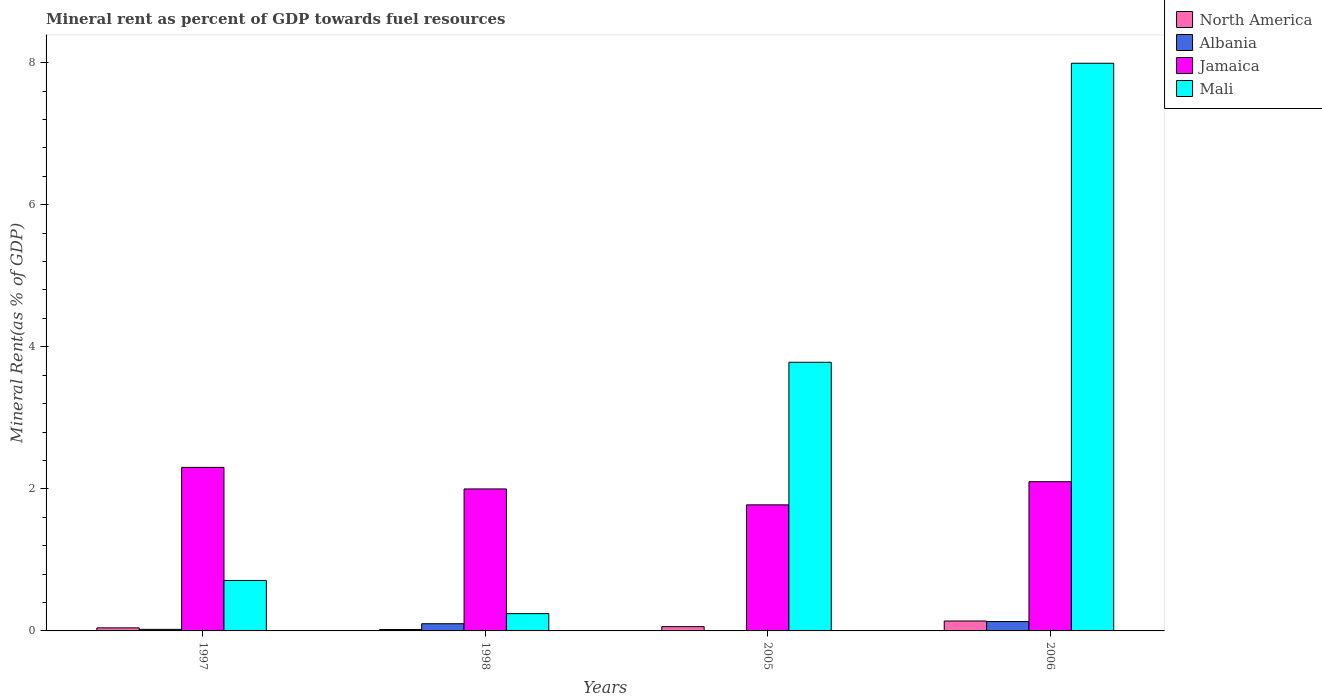How many different coloured bars are there?
Make the answer very short. 4. Are the number of bars per tick equal to the number of legend labels?
Your response must be concise. Yes. What is the mineral rent in Jamaica in 2006?
Keep it short and to the point. 2.1. Across all years, what is the maximum mineral rent in Mali?
Offer a very short reply. 7.99. Across all years, what is the minimum mineral rent in North America?
Provide a short and direct response. 0.02. In which year was the mineral rent in Mali maximum?
Provide a short and direct response. 2006. What is the total mineral rent in North America in the graph?
Provide a succinct answer. 0.26. What is the difference between the mineral rent in Albania in 1997 and that in 1998?
Ensure brevity in your answer.  -0.08. What is the difference between the mineral rent in Mali in 2005 and the mineral rent in Albania in 1998?
Offer a very short reply. 3.68. What is the average mineral rent in Jamaica per year?
Offer a terse response. 2.04. In the year 2005, what is the difference between the mineral rent in North America and mineral rent in Albania?
Make the answer very short. 0.06. What is the ratio of the mineral rent in Jamaica in 1998 to that in 2006?
Offer a very short reply. 0.95. Is the difference between the mineral rent in North America in 1997 and 2006 greater than the difference between the mineral rent in Albania in 1997 and 2006?
Ensure brevity in your answer.  Yes. What is the difference between the highest and the second highest mineral rent in North America?
Offer a very short reply. 0.08. What is the difference between the highest and the lowest mineral rent in Mali?
Your response must be concise. 7.75. In how many years, is the mineral rent in Albania greater than the average mineral rent in Albania taken over all years?
Offer a terse response. 2. Is the sum of the mineral rent in Jamaica in 1998 and 2005 greater than the maximum mineral rent in Albania across all years?
Keep it short and to the point. Yes. Is it the case that in every year, the sum of the mineral rent in Mali and mineral rent in North America is greater than the sum of mineral rent in Albania and mineral rent in Jamaica?
Provide a short and direct response. Yes. What does the 3rd bar from the left in 2006 represents?
Provide a short and direct response. Jamaica. Are all the bars in the graph horizontal?
Your response must be concise. No. How many years are there in the graph?
Give a very brief answer. 4. Does the graph contain any zero values?
Offer a very short reply. No. Does the graph contain grids?
Keep it short and to the point. No. Where does the legend appear in the graph?
Offer a terse response. Top right. What is the title of the graph?
Your answer should be compact. Mineral rent as percent of GDP towards fuel resources. Does "United Arab Emirates" appear as one of the legend labels in the graph?
Keep it short and to the point. No. What is the label or title of the X-axis?
Keep it short and to the point. Years. What is the label or title of the Y-axis?
Your answer should be very brief. Mineral Rent(as % of GDP). What is the Mineral Rent(as % of GDP) in North America in 1997?
Your answer should be very brief. 0.04. What is the Mineral Rent(as % of GDP) in Albania in 1997?
Keep it short and to the point. 0.02. What is the Mineral Rent(as % of GDP) of Jamaica in 1997?
Give a very brief answer. 2.3. What is the Mineral Rent(as % of GDP) of Mali in 1997?
Your response must be concise. 0.71. What is the Mineral Rent(as % of GDP) in North America in 1998?
Provide a short and direct response. 0.02. What is the Mineral Rent(as % of GDP) in Albania in 1998?
Give a very brief answer. 0.1. What is the Mineral Rent(as % of GDP) of Jamaica in 1998?
Ensure brevity in your answer.  2. What is the Mineral Rent(as % of GDP) of Mali in 1998?
Offer a very short reply. 0.24. What is the Mineral Rent(as % of GDP) in North America in 2005?
Make the answer very short. 0.06. What is the Mineral Rent(as % of GDP) in Albania in 2005?
Give a very brief answer. 0. What is the Mineral Rent(as % of GDP) in Jamaica in 2005?
Provide a succinct answer. 1.77. What is the Mineral Rent(as % of GDP) in Mali in 2005?
Offer a very short reply. 3.78. What is the Mineral Rent(as % of GDP) of North America in 2006?
Your answer should be compact. 0.14. What is the Mineral Rent(as % of GDP) of Albania in 2006?
Your response must be concise. 0.13. What is the Mineral Rent(as % of GDP) in Jamaica in 2006?
Make the answer very short. 2.1. What is the Mineral Rent(as % of GDP) of Mali in 2006?
Ensure brevity in your answer.  7.99. Across all years, what is the maximum Mineral Rent(as % of GDP) in North America?
Your answer should be very brief. 0.14. Across all years, what is the maximum Mineral Rent(as % of GDP) in Albania?
Offer a very short reply. 0.13. Across all years, what is the maximum Mineral Rent(as % of GDP) of Jamaica?
Provide a short and direct response. 2.3. Across all years, what is the maximum Mineral Rent(as % of GDP) in Mali?
Your answer should be compact. 7.99. Across all years, what is the minimum Mineral Rent(as % of GDP) in North America?
Your answer should be very brief. 0.02. Across all years, what is the minimum Mineral Rent(as % of GDP) of Albania?
Make the answer very short. 0. Across all years, what is the minimum Mineral Rent(as % of GDP) in Jamaica?
Your answer should be very brief. 1.77. Across all years, what is the minimum Mineral Rent(as % of GDP) in Mali?
Ensure brevity in your answer.  0.24. What is the total Mineral Rent(as % of GDP) of North America in the graph?
Provide a succinct answer. 0.26. What is the total Mineral Rent(as % of GDP) in Albania in the graph?
Make the answer very short. 0.26. What is the total Mineral Rent(as % of GDP) of Jamaica in the graph?
Offer a terse response. 8.18. What is the total Mineral Rent(as % of GDP) of Mali in the graph?
Your response must be concise. 12.73. What is the difference between the Mineral Rent(as % of GDP) of North America in 1997 and that in 1998?
Provide a short and direct response. 0.02. What is the difference between the Mineral Rent(as % of GDP) in Albania in 1997 and that in 1998?
Ensure brevity in your answer.  -0.08. What is the difference between the Mineral Rent(as % of GDP) of Jamaica in 1997 and that in 1998?
Your answer should be compact. 0.3. What is the difference between the Mineral Rent(as % of GDP) in Mali in 1997 and that in 1998?
Your answer should be compact. 0.47. What is the difference between the Mineral Rent(as % of GDP) of North America in 1997 and that in 2005?
Your answer should be very brief. -0.02. What is the difference between the Mineral Rent(as % of GDP) of Albania in 1997 and that in 2005?
Provide a succinct answer. 0.02. What is the difference between the Mineral Rent(as % of GDP) in Jamaica in 1997 and that in 2005?
Make the answer very short. 0.53. What is the difference between the Mineral Rent(as % of GDP) in Mali in 1997 and that in 2005?
Make the answer very short. -3.07. What is the difference between the Mineral Rent(as % of GDP) in North America in 1997 and that in 2006?
Give a very brief answer. -0.1. What is the difference between the Mineral Rent(as % of GDP) in Albania in 1997 and that in 2006?
Ensure brevity in your answer.  -0.11. What is the difference between the Mineral Rent(as % of GDP) in Jamaica in 1997 and that in 2006?
Offer a terse response. 0.2. What is the difference between the Mineral Rent(as % of GDP) in Mali in 1997 and that in 2006?
Provide a succinct answer. -7.28. What is the difference between the Mineral Rent(as % of GDP) in North America in 1998 and that in 2005?
Offer a terse response. -0.04. What is the difference between the Mineral Rent(as % of GDP) in Albania in 1998 and that in 2005?
Offer a terse response. 0.1. What is the difference between the Mineral Rent(as % of GDP) of Jamaica in 1998 and that in 2005?
Offer a terse response. 0.22. What is the difference between the Mineral Rent(as % of GDP) of Mali in 1998 and that in 2005?
Provide a short and direct response. -3.54. What is the difference between the Mineral Rent(as % of GDP) in North America in 1998 and that in 2006?
Provide a succinct answer. -0.12. What is the difference between the Mineral Rent(as % of GDP) of Albania in 1998 and that in 2006?
Your answer should be very brief. -0.03. What is the difference between the Mineral Rent(as % of GDP) in Jamaica in 1998 and that in 2006?
Your answer should be compact. -0.1. What is the difference between the Mineral Rent(as % of GDP) of Mali in 1998 and that in 2006?
Make the answer very short. -7.75. What is the difference between the Mineral Rent(as % of GDP) in North America in 2005 and that in 2006?
Provide a succinct answer. -0.08. What is the difference between the Mineral Rent(as % of GDP) in Albania in 2005 and that in 2006?
Ensure brevity in your answer.  -0.13. What is the difference between the Mineral Rent(as % of GDP) of Jamaica in 2005 and that in 2006?
Your answer should be compact. -0.33. What is the difference between the Mineral Rent(as % of GDP) in Mali in 2005 and that in 2006?
Offer a very short reply. -4.21. What is the difference between the Mineral Rent(as % of GDP) of North America in 1997 and the Mineral Rent(as % of GDP) of Albania in 1998?
Your answer should be compact. -0.06. What is the difference between the Mineral Rent(as % of GDP) of North America in 1997 and the Mineral Rent(as % of GDP) of Jamaica in 1998?
Your answer should be compact. -1.96. What is the difference between the Mineral Rent(as % of GDP) of North America in 1997 and the Mineral Rent(as % of GDP) of Mali in 1998?
Make the answer very short. -0.2. What is the difference between the Mineral Rent(as % of GDP) in Albania in 1997 and the Mineral Rent(as % of GDP) in Jamaica in 1998?
Give a very brief answer. -1.98. What is the difference between the Mineral Rent(as % of GDP) in Albania in 1997 and the Mineral Rent(as % of GDP) in Mali in 1998?
Keep it short and to the point. -0.22. What is the difference between the Mineral Rent(as % of GDP) of Jamaica in 1997 and the Mineral Rent(as % of GDP) of Mali in 1998?
Offer a terse response. 2.06. What is the difference between the Mineral Rent(as % of GDP) of North America in 1997 and the Mineral Rent(as % of GDP) of Albania in 2005?
Provide a succinct answer. 0.04. What is the difference between the Mineral Rent(as % of GDP) of North America in 1997 and the Mineral Rent(as % of GDP) of Jamaica in 2005?
Offer a terse response. -1.73. What is the difference between the Mineral Rent(as % of GDP) of North America in 1997 and the Mineral Rent(as % of GDP) of Mali in 2005?
Make the answer very short. -3.74. What is the difference between the Mineral Rent(as % of GDP) of Albania in 1997 and the Mineral Rent(as % of GDP) of Jamaica in 2005?
Offer a very short reply. -1.75. What is the difference between the Mineral Rent(as % of GDP) in Albania in 1997 and the Mineral Rent(as % of GDP) in Mali in 2005?
Your response must be concise. -3.76. What is the difference between the Mineral Rent(as % of GDP) in Jamaica in 1997 and the Mineral Rent(as % of GDP) in Mali in 2005?
Keep it short and to the point. -1.48. What is the difference between the Mineral Rent(as % of GDP) in North America in 1997 and the Mineral Rent(as % of GDP) in Albania in 2006?
Make the answer very short. -0.09. What is the difference between the Mineral Rent(as % of GDP) of North America in 1997 and the Mineral Rent(as % of GDP) of Jamaica in 2006?
Keep it short and to the point. -2.06. What is the difference between the Mineral Rent(as % of GDP) of North America in 1997 and the Mineral Rent(as % of GDP) of Mali in 2006?
Ensure brevity in your answer.  -7.95. What is the difference between the Mineral Rent(as % of GDP) of Albania in 1997 and the Mineral Rent(as % of GDP) of Jamaica in 2006?
Provide a short and direct response. -2.08. What is the difference between the Mineral Rent(as % of GDP) in Albania in 1997 and the Mineral Rent(as % of GDP) in Mali in 2006?
Provide a succinct answer. -7.97. What is the difference between the Mineral Rent(as % of GDP) of Jamaica in 1997 and the Mineral Rent(as % of GDP) of Mali in 2006?
Give a very brief answer. -5.69. What is the difference between the Mineral Rent(as % of GDP) of North America in 1998 and the Mineral Rent(as % of GDP) of Albania in 2005?
Provide a succinct answer. 0.02. What is the difference between the Mineral Rent(as % of GDP) in North America in 1998 and the Mineral Rent(as % of GDP) in Jamaica in 2005?
Offer a very short reply. -1.75. What is the difference between the Mineral Rent(as % of GDP) in North America in 1998 and the Mineral Rent(as % of GDP) in Mali in 2005?
Offer a terse response. -3.76. What is the difference between the Mineral Rent(as % of GDP) in Albania in 1998 and the Mineral Rent(as % of GDP) in Jamaica in 2005?
Offer a very short reply. -1.67. What is the difference between the Mineral Rent(as % of GDP) of Albania in 1998 and the Mineral Rent(as % of GDP) of Mali in 2005?
Your response must be concise. -3.68. What is the difference between the Mineral Rent(as % of GDP) in Jamaica in 1998 and the Mineral Rent(as % of GDP) in Mali in 2005?
Keep it short and to the point. -1.78. What is the difference between the Mineral Rent(as % of GDP) in North America in 1998 and the Mineral Rent(as % of GDP) in Albania in 2006?
Make the answer very short. -0.11. What is the difference between the Mineral Rent(as % of GDP) of North America in 1998 and the Mineral Rent(as % of GDP) of Jamaica in 2006?
Offer a terse response. -2.08. What is the difference between the Mineral Rent(as % of GDP) in North America in 1998 and the Mineral Rent(as % of GDP) in Mali in 2006?
Your answer should be very brief. -7.97. What is the difference between the Mineral Rent(as % of GDP) in Albania in 1998 and the Mineral Rent(as % of GDP) in Jamaica in 2006?
Give a very brief answer. -2. What is the difference between the Mineral Rent(as % of GDP) of Albania in 1998 and the Mineral Rent(as % of GDP) of Mali in 2006?
Provide a short and direct response. -7.89. What is the difference between the Mineral Rent(as % of GDP) in Jamaica in 1998 and the Mineral Rent(as % of GDP) in Mali in 2006?
Your response must be concise. -5.99. What is the difference between the Mineral Rent(as % of GDP) in North America in 2005 and the Mineral Rent(as % of GDP) in Albania in 2006?
Your response must be concise. -0.07. What is the difference between the Mineral Rent(as % of GDP) in North America in 2005 and the Mineral Rent(as % of GDP) in Jamaica in 2006?
Keep it short and to the point. -2.04. What is the difference between the Mineral Rent(as % of GDP) of North America in 2005 and the Mineral Rent(as % of GDP) of Mali in 2006?
Offer a terse response. -7.93. What is the difference between the Mineral Rent(as % of GDP) of Albania in 2005 and the Mineral Rent(as % of GDP) of Jamaica in 2006?
Make the answer very short. -2.1. What is the difference between the Mineral Rent(as % of GDP) of Albania in 2005 and the Mineral Rent(as % of GDP) of Mali in 2006?
Your answer should be compact. -7.99. What is the difference between the Mineral Rent(as % of GDP) in Jamaica in 2005 and the Mineral Rent(as % of GDP) in Mali in 2006?
Provide a succinct answer. -6.22. What is the average Mineral Rent(as % of GDP) of North America per year?
Offer a terse response. 0.07. What is the average Mineral Rent(as % of GDP) in Albania per year?
Offer a very short reply. 0.06. What is the average Mineral Rent(as % of GDP) in Jamaica per year?
Give a very brief answer. 2.04. What is the average Mineral Rent(as % of GDP) of Mali per year?
Provide a succinct answer. 3.18. In the year 1997, what is the difference between the Mineral Rent(as % of GDP) of North America and Mineral Rent(as % of GDP) of Albania?
Provide a short and direct response. 0.02. In the year 1997, what is the difference between the Mineral Rent(as % of GDP) of North America and Mineral Rent(as % of GDP) of Jamaica?
Your answer should be very brief. -2.26. In the year 1997, what is the difference between the Mineral Rent(as % of GDP) in North America and Mineral Rent(as % of GDP) in Mali?
Your answer should be compact. -0.67. In the year 1997, what is the difference between the Mineral Rent(as % of GDP) of Albania and Mineral Rent(as % of GDP) of Jamaica?
Your answer should be compact. -2.28. In the year 1997, what is the difference between the Mineral Rent(as % of GDP) in Albania and Mineral Rent(as % of GDP) in Mali?
Your response must be concise. -0.69. In the year 1997, what is the difference between the Mineral Rent(as % of GDP) of Jamaica and Mineral Rent(as % of GDP) of Mali?
Ensure brevity in your answer.  1.59. In the year 1998, what is the difference between the Mineral Rent(as % of GDP) in North America and Mineral Rent(as % of GDP) in Albania?
Provide a succinct answer. -0.08. In the year 1998, what is the difference between the Mineral Rent(as % of GDP) of North America and Mineral Rent(as % of GDP) of Jamaica?
Provide a short and direct response. -1.98. In the year 1998, what is the difference between the Mineral Rent(as % of GDP) in North America and Mineral Rent(as % of GDP) in Mali?
Make the answer very short. -0.22. In the year 1998, what is the difference between the Mineral Rent(as % of GDP) of Albania and Mineral Rent(as % of GDP) of Jamaica?
Give a very brief answer. -1.9. In the year 1998, what is the difference between the Mineral Rent(as % of GDP) of Albania and Mineral Rent(as % of GDP) of Mali?
Your answer should be compact. -0.14. In the year 1998, what is the difference between the Mineral Rent(as % of GDP) of Jamaica and Mineral Rent(as % of GDP) of Mali?
Provide a succinct answer. 1.75. In the year 2005, what is the difference between the Mineral Rent(as % of GDP) in North America and Mineral Rent(as % of GDP) in Albania?
Offer a very short reply. 0.06. In the year 2005, what is the difference between the Mineral Rent(as % of GDP) in North America and Mineral Rent(as % of GDP) in Jamaica?
Provide a succinct answer. -1.71. In the year 2005, what is the difference between the Mineral Rent(as % of GDP) in North America and Mineral Rent(as % of GDP) in Mali?
Provide a short and direct response. -3.72. In the year 2005, what is the difference between the Mineral Rent(as % of GDP) in Albania and Mineral Rent(as % of GDP) in Jamaica?
Give a very brief answer. -1.77. In the year 2005, what is the difference between the Mineral Rent(as % of GDP) of Albania and Mineral Rent(as % of GDP) of Mali?
Your answer should be very brief. -3.78. In the year 2005, what is the difference between the Mineral Rent(as % of GDP) in Jamaica and Mineral Rent(as % of GDP) in Mali?
Offer a terse response. -2.01. In the year 2006, what is the difference between the Mineral Rent(as % of GDP) of North America and Mineral Rent(as % of GDP) of Albania?
Provide a succinct answer. 0.01. In the year 2006, what is the difference between the Mineral Rent(as % of GDP) of North America and Mineral Rent(as % of GDP) of Jamaica?
Provide a succinct answer. -1.96. In the year 2006, what is the difference between the Mineral Rent(as % of GDP) of North America and Mineral Rent(as % of GDP) of Mali?
Ensure brevity in your answer.  -7.85. In the year 2006, what is the difference between the Mineral Rent(as % of GDP) of Albania and Mineral Rent(as % of GDP) of Jamaica?
Your answer should be very brief. -1.97. In the year 2006, what is the difference between the Mineral Rent(as % of GDP) in Albania and Mineral Rent(as % of GDP) in Mali?
Ensure brevity in your answer.  -7.86. In the year 2006, what is the difference between the Mineral Rent(as % of GDP) in Jamaica and Mineral Rent(as % of GDP) in Mali?
Your answer should be very brief. -5.89. What is the ratio of the Mineral Rent(as % of GDP) of North America in 1997 to that in 1998?
Your answer should be compact. 2.18. What is the ratio of the Mineral Rent(as % of GDP) of Albania in 1997 to that in 1998?
Keep it short and to the point. 0.22. What is the ratio of the Mineral Rent(as % of GDP) in Jamaica in 1997 to that in 1998?
Keep it short and to the point. 1.15. What is the ratio of the Mineral Rent(as % of GDP) of Mali in 1997 to that in 1998?
Provide a short and direct response. 2.92. What is the ratio of the Mineral Rent(as % of GDP) in North America in 1997 to that in 2005?
Ensure brevity in your answer.  0.72. What is the ratio of the Mineral Rent(as % of GDP) in Albania in 1997 to that in 2005?
Make the answer very short. 31.11. What is the ratio of the Mineral Rent(as % of GDP) in Jamaica in 1997 to that in 2005?
Offer a very short reply. 1.3. What is the ratio of the Mineral Rent(as % of GDP) in Mali in 1997 to that in 2005?
Offer a terse response. 0.19. What is the ratio of the Mineral Rent(as % of GDP) of North America in 1997 to that in 2006?
Provide a short and direct response. 0.31. What is the ratio of the Mineral Rent(as % of GDP) in Albania in 1997 to that in 2006?
Your answer should be very brief. 0.17. What is the ratio of the Mineral Rent(as % of GDP) of Jamaica in 1997 to that in 2006?
Offer a terse response. 1.1. What is the ratio of the Mineral Rent(as % of GDP) of Mali in 1997 to that in 2006?
Your response must be concise. 0.09. What is the ratio of the Mineral Rent(as % of GDP) in North America in 1998 to that in 2005?
Keep it short and to the point. 0.33. What is the ratio of the Mineral Rent(as % of GDP) in Albania in 1998 to that in 2005?
Keep it short and to the point. 142.29. What is the ratio of the Mineral Rent(as % of GDP) of Jamaica in 1998 to that in 2005?
Offer a terse response. 1.13. What is the ratio of the Mineral Rent(as % of GDP) in Mali in 1998 to that in 2005?
Ensure brevity in your answer.  0.06. What is the ratio of the Mineral Rent(as % of GDP) in North America in 1998 to that in 2006?
Provide a short and direct response. 0.14. What is the ratio of the Mineral Rent(as % of GDP) in Albania in 1998 to that in 2006?
Your response must be concise. 0.77. What is the ratio of the Mineral Rent(as % of GDP) of Jamaica in 1998 to that in 2006?
Offer a very short reply. 0.95. What is the ratio of the Mineral Rent(as % of GDP) of Mali in 1998 to that in 2006?
Give a very brief answer. 0.03. What is the ratio of the Mineral Rent(as % of GDP) in North America in 2005 to that in 2006?
Give a very brief answer. 0.43. What is the ratio of the Mineral Rent(as % of GDP) of Albania in 2005 to that in 2006?
Keep it short and to the point. 0.01. What is the ratio of the Mineral Rent(as % of GDP) of Jamaica in 2005 to that in 2006?
Provide a short and direct response. 0.84. What is the ratio of the Mineral Rent(as % of GDP) of Mali in 2005 to that in 2006?
Your answer should be compact. 0.47. What is the difference between the highest and the second highest Mineral Rent(as % of GDP) of North America?
Provide a short and direct response. 0.08. What is the difference between the highest and the second highest Mineral Rent(as % of GDP) of Albania?
Ensure brevity in your answer.  0.03. What is the difference between the highest and the second highest Mineral Rent(as % of GDP) in Jamaica?
Your answer should be very brief. 0.2. What is the difference between the highest and the second highest Mineral Rent(as % of GDP) of Mali?
Your answer should be very brief. 4.21. What is the difference between the highest and the lowest Mineral Rent(as % of GDP) in North America?
Ensure brevity in your answer.  0.12. What is the difference between the highest and the lowest Mineral Rent(as % of GDP) of Albania?
Your answer should be very brief. 0.13. What is the difference between the highest and the lowest Mineral Rent(as % of GDP) of Jamaica?
Make the answer very short. 0.53. What is the difference between the highest and the lowest Mineral Rent(as % of GDP) of Mali?
Keep it short and to the point. 7.75. 